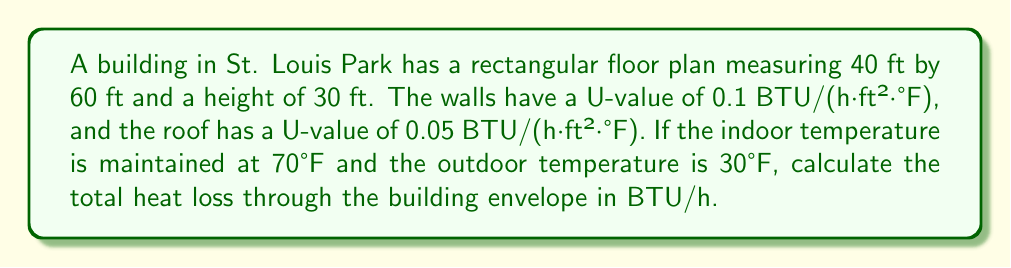Solve this math problem. To calculate the total heat loss through the building envelope, we need to follow these steps:

1. Calculate the surface areas:
   - Wall area: $A_w = 2(40 + 60) \times 30 = 6000$ ft²
   - Roof area: $A_r = 40 \times 60 = 2400$ ft²

2. Calculate the temperature difference:
   $\Delta T = 70°F - 30°F = 40°F$

3. Calculate heat loss through walls:
   $Q_w = U_w \times A_w \times \Delta T$
   $Q_w = 0.1 \text{ BTU/(h·ft²·°F)} \times 6000 \text{ ft²} \times 40°F = 24000 \text{ BTU/h}$

4. Calculate heat loss through roof:
   $Q_r = U_r \times A_r \times \Delta T$
   $Q_r = 0.05 \text{ BTU/(h·ft²·°F)} \times 2400 \text{ ft²} \times 40°F = 4800 \text{ BTU/h}$

5. Calculate total heat loss:
   $Q_{\text{total}} = Q_w + Q_r = 24000 \text{ BTU/h} + 4800 \text{ BTU/h} = 28800 \text{ BTU/h}$
Answer: 28800 BTU/h 